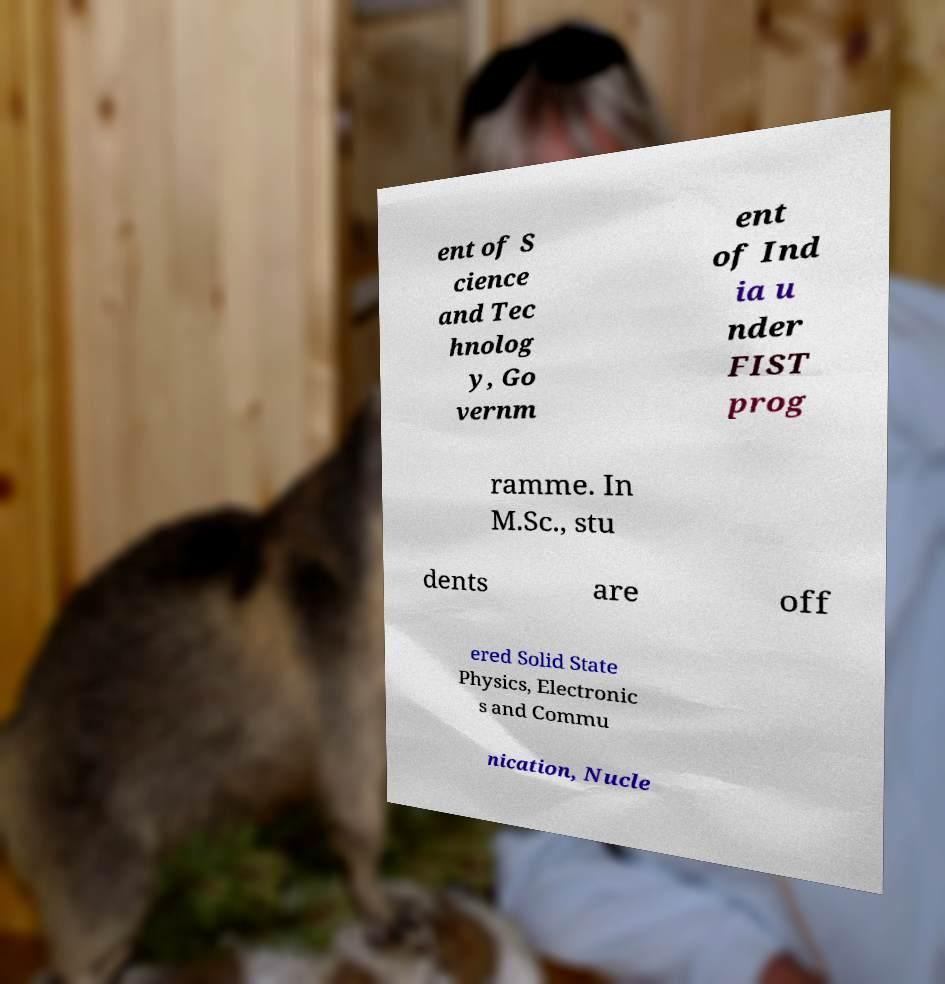Can you read and provide the text displayed in the image?This photo seems to have some interesting text. Can you extract and type it out for me? ent of S cience and Tec hnolog y, Go vernm ent of Ind ia u nder FIST prog ramme. In M.Sc., stu dents are off ered Solid State Physics, Electronic s and Commu nication, Nucle 